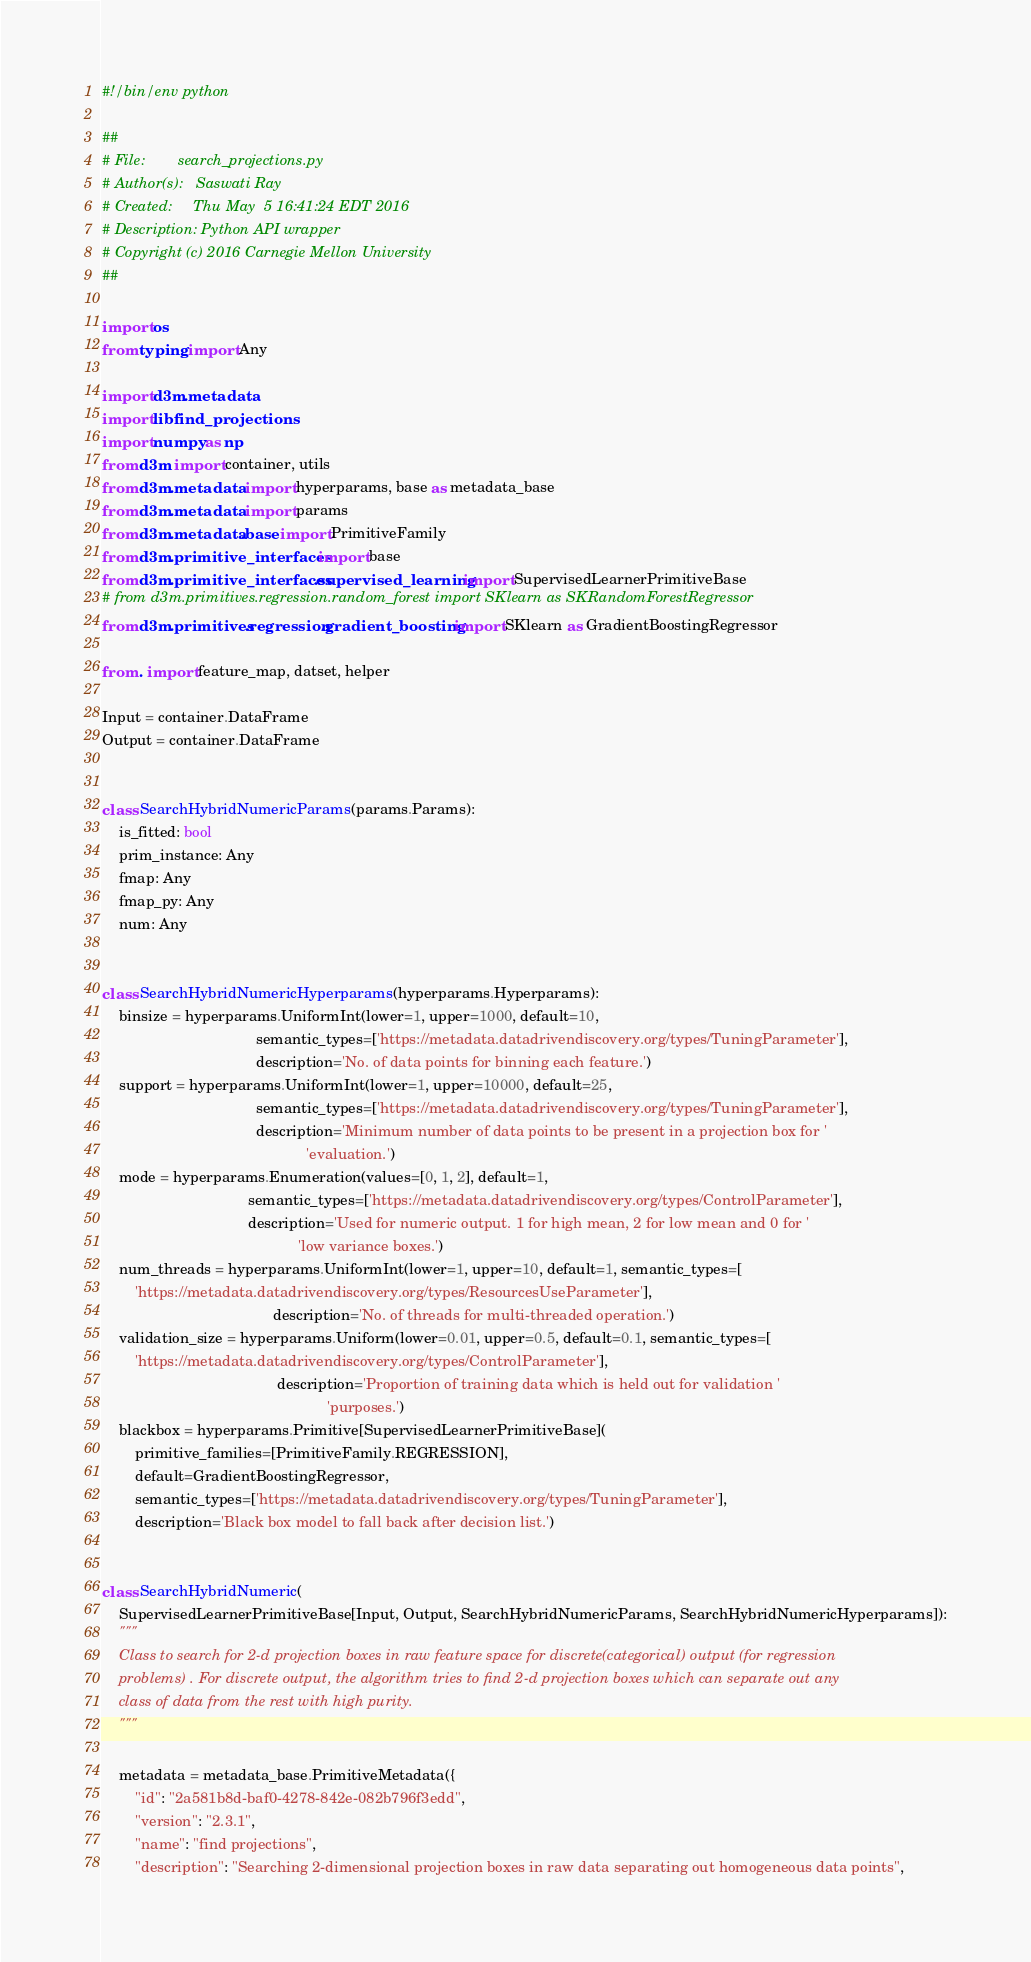<code> <loc_0><loc_0><loc_500><loc_500><_Python_>#!/bin/env python

##
# File:        search_projections.py
# Author(s):   Saswati Ray
# Created:     Thu May  5 16:41:24 EDT 2016
# Description: Python API wrapper
# Copyright (c) 2016 Carnegie Mellon University
##

import os
from typing import Any

import d3m.metadata
import libfind_projections
import numpy as np
from d3m import container, utils
from d3m.metadata import hyperparams, base as metadata_base
from d3m.metadata import params
from d3m.metadata.base import PrimitiveFamily
from d3m.primitive_interfaces import base
from d3m.primitive_interfaces.supervised_learning import SupervisedLearnerPrimitiveBase
# from d3m.primitives.regression.random_forest import SKlearn as SKRandomForestRegressor
from d3m.primitives.regression.gradient_boosting import SKlearn as GradientBoostingRegressor

from . import feature_map, datset, helper

Input = container.DataFrame
Output = container.DataFrame


class SearchHybridNumericParams(params.Params):
    is_fitted: bool
    prim_instance: Any
    fmap: Any
    fmap_py: Any
    num: Any


class SearchHybridNumericHyperparams(hyperparams.Hyperparams):
    binsize = hyperparams.UniformInt(lower=1, upper=1000, default=10,
                                     semantic_types=['https://metadata.datadrivendiscovery.org/types/TuningParameter'],
                                     description='No. of data points for binning each feature.')
    support = hyperparams.UniformInt(lower=1, upper=10000, default=25,
                                     semantic_types=['https://metadata.datadrivendiscovery.org/types/TuningParameter'],
                                     description='Minimum number of data points to be present in a projection box for '
                                                 'evaluation.')
    mode = hyperparams.Enumeration(values=[0, 1, 2], default=1,
                                   semantic_types=['https://metadata.datadrivendiscovery.org/types/ControlParameter'],
                                   description='Used for numeric output. 1 for high mean, 2 for low mean and 0 for '
                                               'low variance boxes.')
    num_threads = hyperparams.UniformInt(lower=1, upper=10, default=1, semantic_types=[
        'https://metadata.datadrivendiscovery.org/types/ResourcesUseParameter'],
                                         description='No. of threads for multi-threaded operation.')
    validation_size = hyperparams.Uniform(lower=0.01, upper=0.5, default=0.1, semantic_types=[
        'https://metadata.datadrivendiscovery.org/types/ControlParameter'],
                                          description='Proportion of training data which is held out for validation '
                                                      'purposes.')
    blackbox = hyperparams.Primitive[SupervisedLearnerPrimitiveBase](
        primitive_families=[PrimitiveFamily.REGRESSION],
        default=GradientBoostingRegressor,
        semantic_types=['https://metadata.datadrivendiscovery.org/types/TuningParameter'],
        description='Black box model to fall back after decision list.')


class SearchHybridNumeric(
    SupervisedLearnerPrimitiveBase[Input, Output, SearchHybridNumericParams, SearchHybridNumericHyperparams]):
    """
    Class to search for 2-d projection boxes in raw feature space for discrete(categorical) output (for regression
    problems) . For discrete output, the algorithm tries to find 2-d projection boxes which can separate out any
    class of data from the rest with high purity.
    """

    metadata = metadata_base.PrimitiveMetadata({
        "id": "2a581b8d-baf0-4278-842e-082b796f3edd",
        "version": "2.3.1",
        "name": "find projections",
        "description": "Searching 2-dimensional projection boxes in raw data separating out homogeneous data points",</code> 